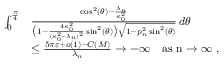Convert formula to latex. <formula><loc_0><loc_0><loc_500><loc_500>\begin{array} { r l } { \int _ { 0 } ^ { \frac { \pi } { 4 } } } & { \frac { \cos ^ { 2 } ( \theta ) - \frac { \lambda _ { n } } { \kappa _ { 0 } ^ { 2 } } } { \left ( 1 - \frac { 4 \kappa _ { 0 } ^ { 2 } } { ( \kappa _ { 0 } ^ { 2 } - \lambda _ { n } ) ^ { 2 } } \sin ^ { 2 } ( \theta ) \right ) \sqrt { 1 - p _ { n } ^ { 2 } \sin ^ { 2 } ( \theta ) } } \, d \theta } \\ & { \leq \frac { 5 \pi \varepsilon + o ( 1 ) - C ( M ) } { \lambda _ { n } } \to - \infty \quad a s n \to \infty , } \end{array}</formula> 